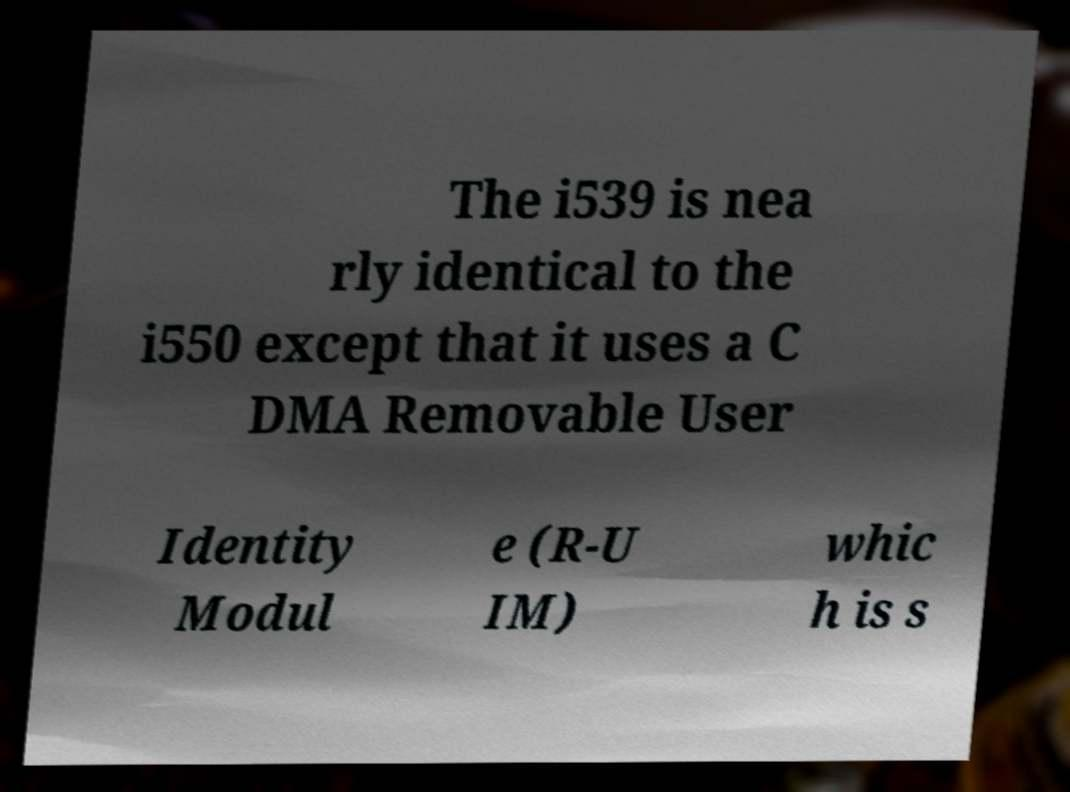Can you read and provide the text displayed in the image?This photo seems to have some interesting text. Can you extract and type it out for me? The i539 is nea rly identical to the i550 except that it uses a C DMA Removable User Identity Modul e (R-U IM) whic h is s 